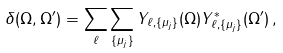<formula> <loc_0><loc_0><loc_500><loc_500>\delta ( \Omega , \Omega ^ { \prime } ) = \sum _ { \ell } \sum _ { \{ \mu _ { j } \} } Y _ { \ell , \{ \mu _ { j } \} } ( \Omega ) Y ^ { * } _ { \ell , \{ \mu _ { j } \} } ( \Omega ^ { \prime } ) \, ,</formula> 